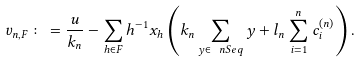Convert formula to latex. <formula><loc_0><loc_0><loc_500><loc_500>v _ { n , F } \colon = \frac { u } { k _ { n } } - \sum _ { h \in F } h ^ { - 1 } x _ { h } \left ( k _ { n } \sum _ { y \in \ n S e q } y + l _ { n } \sum _ { i = 1 } ^ { n } c _ { i } ^ { ( n ) } \right ) .</formula> 